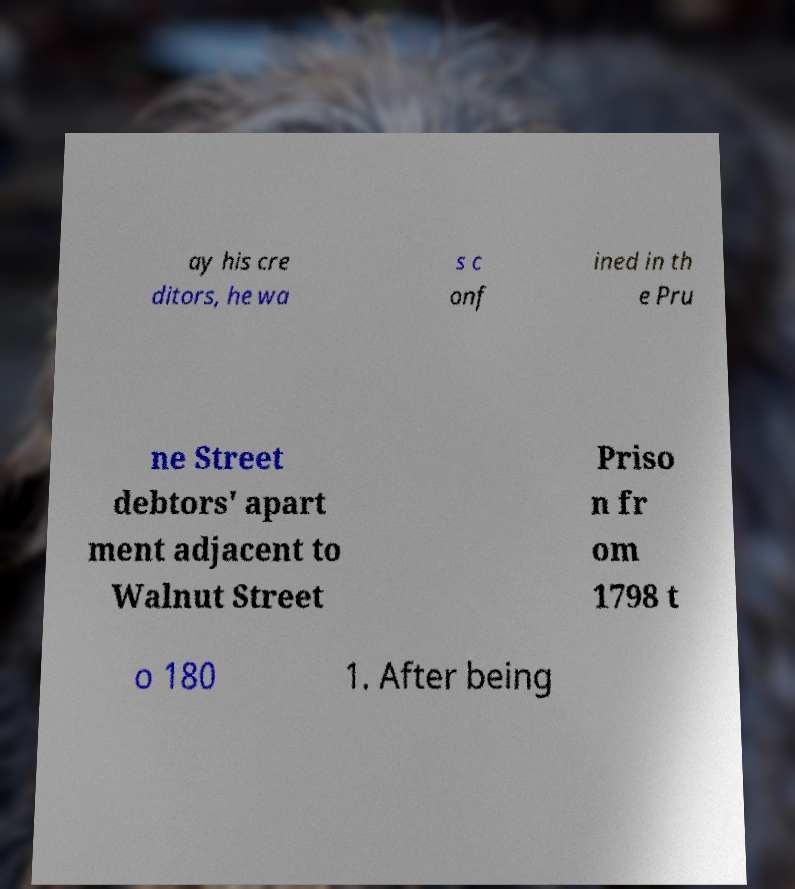Can you read and provide the text displayed in the image?This photo seems to have some interesting text. Can you extract and type it out for me? ay his cre ditors, he wa s c onf ined in th e Pru ne Street debtors' apart ment adjacent to Walnut Street Priso n fr om 1798 t o 180 1. After being 